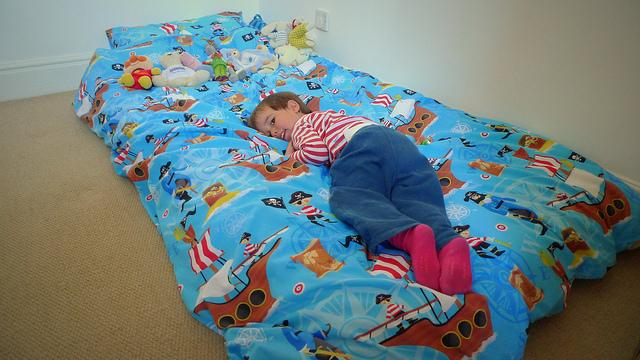Who is joining the boy on his bed? stuffed animals 